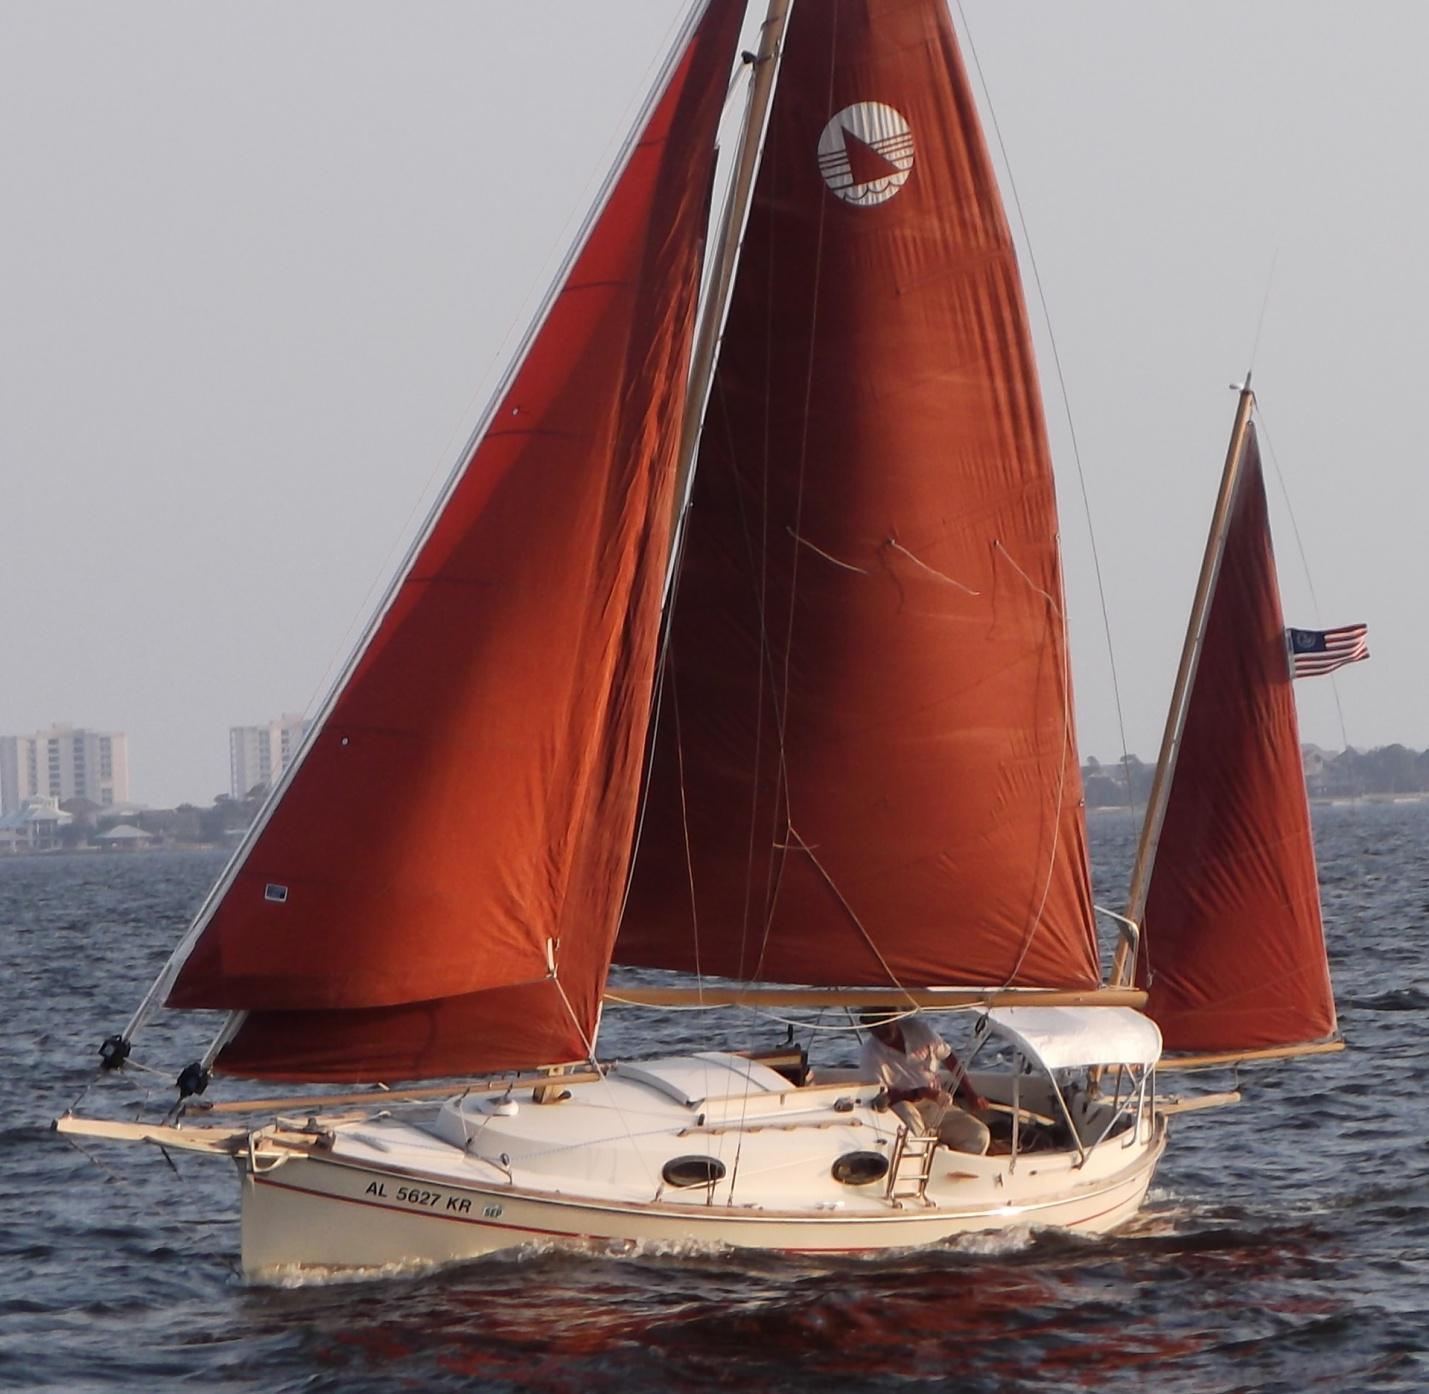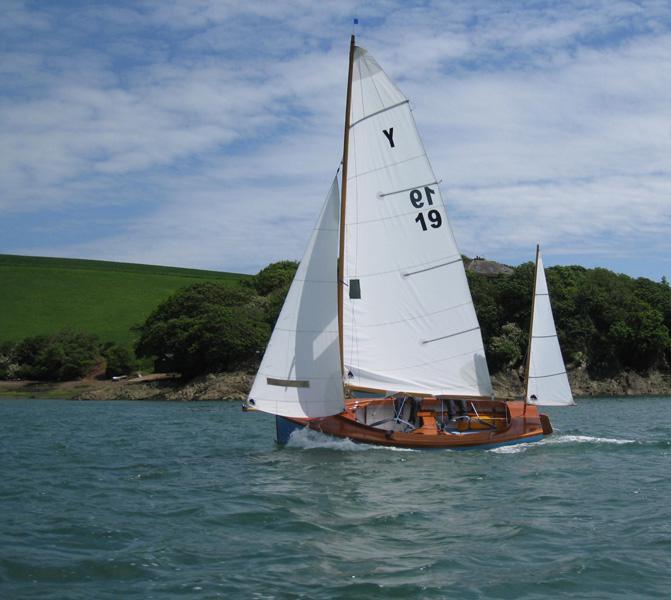The first image is the image on the left, the second image is the image on the right. Analyze the images presented: Is the assertion "A sailboat with red sails is in the water." valid? Answer yes or no. Yes. 